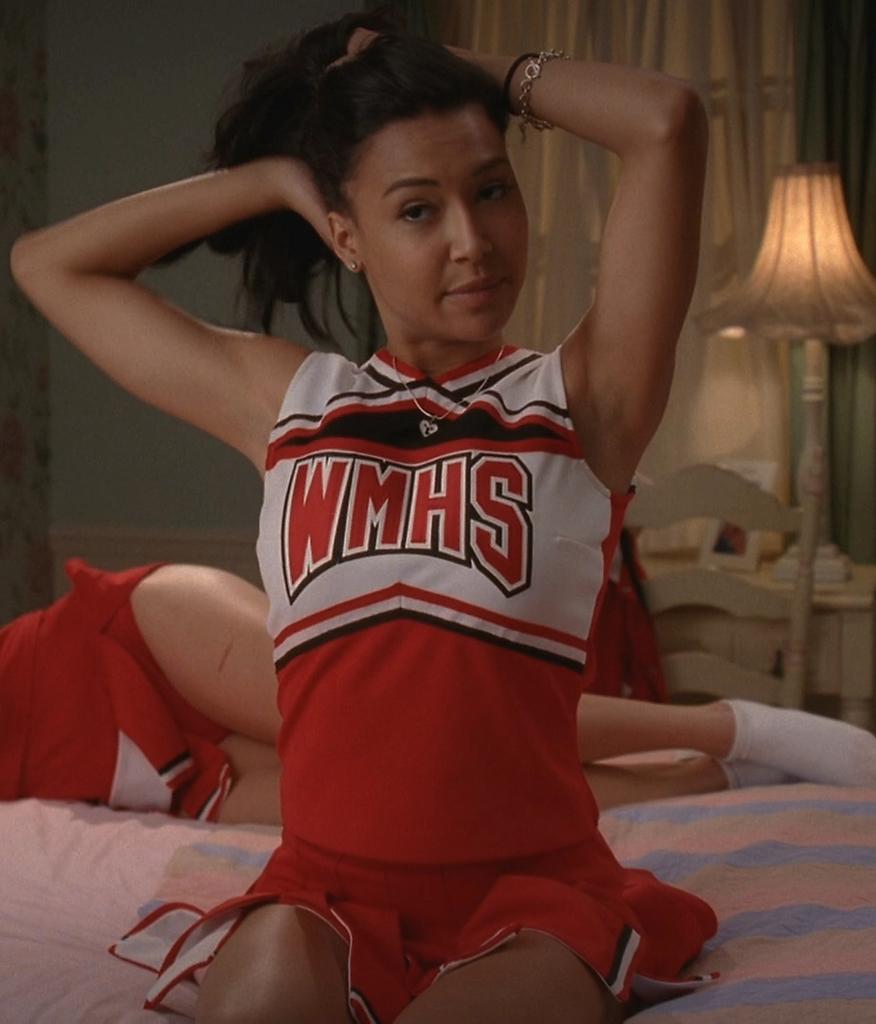Provide a one-sentence caption for the provided image. A WMHS cheerleader sits on a bed in her house. 